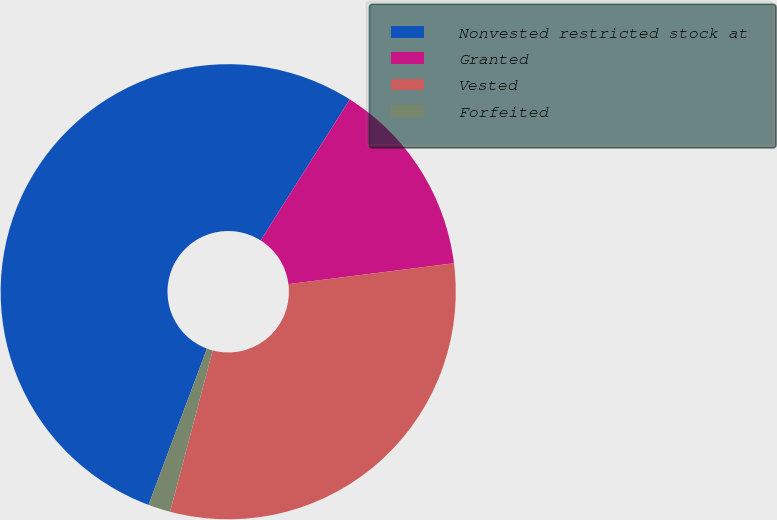Convert chart to OTSL. <chart><loc_0><loc_0><loc_500><loc_500><pie_chart><fcel>Nonvested restricted stock at<fcel>Granted<fcel>Vested<fcel>Forfeited<nl><fcel>53.28%<fcel>14.03%<fcel>31.11%<fcel>1.58%<nl></chart> 